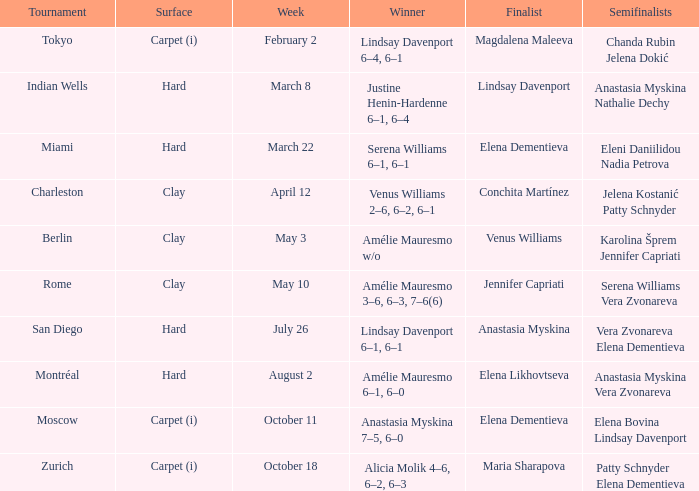Who emerged victorious in the miami competition where elena dementieva reached the finals? Serena Williams 6–1, 6–1. 